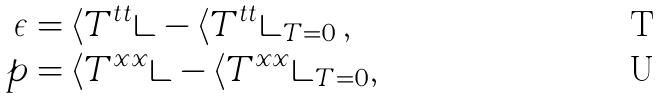<formula> <loc_0><loc_0><loc_500><loc_500>\epsilon & = \langle T ^ { t t } \rangle - \langle T ^ { t t } \rangle _ { T = 0 } \, , \\ p & = \langle T ^ { x x } \rangle - \langle T ^ { x x } \rangle _ { T = 0 } ,</formula> 